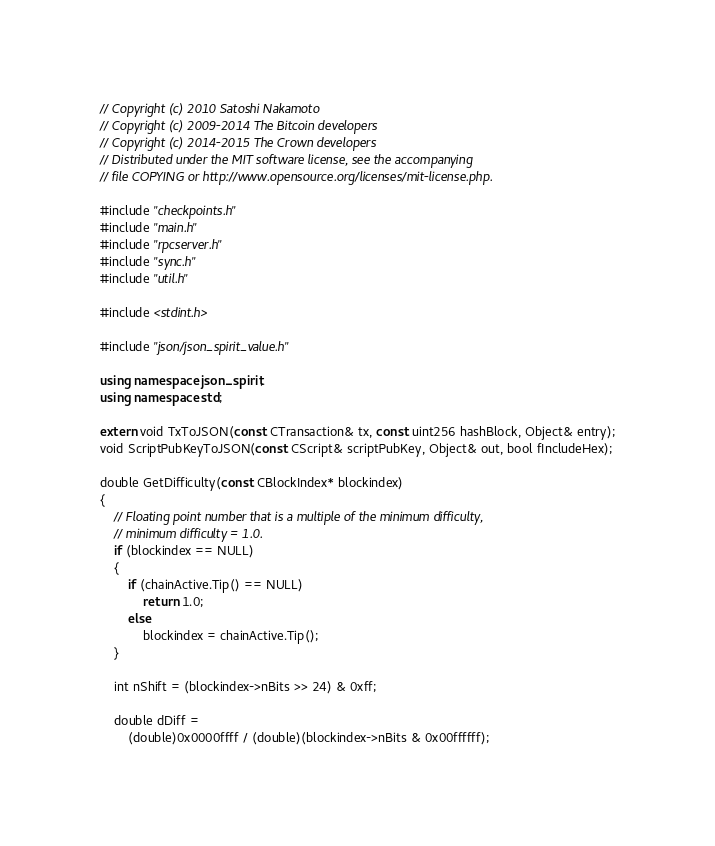Convert code to text. <code><loc_0><loc_0><loc_500><loc_500><_C++_>// Copyright (c) 2010 Satoshi Nakamoto
// Copyright (c) 2009-2014 The Bitcoin developers
// Copyright (c) 2014-2015 The Crown developers
// Distributed under the MIT software license, see the accompanying
// file COPYING or http://www.opensource.org/licenses/mit-license.php.

#include "checkpoints.h"
#include "main.h"
#include "rpcserver.h"
#include "sync.h"
#include "util.h"

#include <stdint.h>

#include "json/json_spirit_value.h"

using namespace json_spirit;
using namespace std;

extern void TxToJSON(const CTransaction& tx, const uint256 hashBlock, Object& entry);
void ScriptPubKeyToJSON(const CScript& scriptPubKey, Object& out, bool fIncludeHex);

double GetDifficulty(const CBlockIndex* blockindex)
{
    // Floating point number that is a multiple of the minimum difficulty,
    // minimum difficulty = 1.0.
    if (blockindex == NULL)
    {
        if (chainActive.Tip() == NULL)
            return 1.0;
        else
            blockindex = chainActive.Tip();
    }

    int nShift = (blockindex->nBits >> 24) & 0xff;

    double dDiff =
        (double)0x0000ffff / (double)(blockindex->nBits & 0x00ffffff);
</code> 